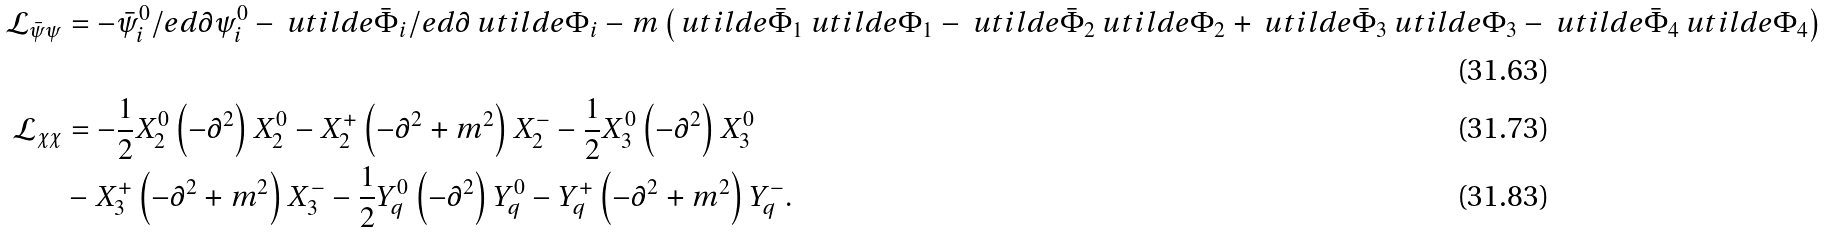Convert formula to latex. <formula><loc_0><loc_0><loc_500><loc_500>\mathcal { L } _ { \bar { \psi } \psi } & = - \bar { \psi } ^ { 0 } _ { i } \slash e d { \partial } \psi ^ { 0 } _ { i } - \ u t i l d e { \bar { \Phi } } _ { i } \slash e d { \partial } \ u t i l d e { \Phi } _ { i } - m \left ( \ u t i l d e { \bar { \Phi } } _ { 1 } \ u t i l d e { \Phi } _ { 1 } - \ u t i l d e { \bar { \Phi } } _ { 2 } \ u t i l d e { \Phi } _ { 2 } + \ u t i l d e { \bar { \Phi } } _ { 3 } \ u t i l d e { \Phi } _ { 3 } - \ u t i l d e { \bar { \Phi } } _ { 4 } \ u t i l d e { \Phi } _ { 4 } \right ) \\ \mathcal { L } _ { \chi \chi } & = - \frac { 1 } { 2 } X _ { 2 } ^ { 0 } \left ( - \partial ^ { 2 } \right ) X _ { 2 } ^ { 0 } - X _ { 2 } ^ { + } \left ( - \partial ^ { 2 } + m ^ { 2 } \right ) X _ { 2 } ^ { - } - \frac { 1 } { 2 } X _ { 3 } ^ { 0 } \left ( - \partial ^ { 2 } \right ) X _ { 3 } ^ { 0 } \\ & - X _ { 3 } ^ { + } \left ( - \partial ^ { 2 } + m ^ { 2 } \right ) X _ { 3 } ^ { - } - \frac { 1 } { 2 } Y _ { q } ^ { 0 } \left ( - \partial ^ { 2 } \right ) Y _ { q } ^ { 0 } - Y _ { q } ^ { + } \left ( - \partial ^ { 2 } + m ^ { 2 } \right ) Y _ { q } ^ { - } .</formula> 